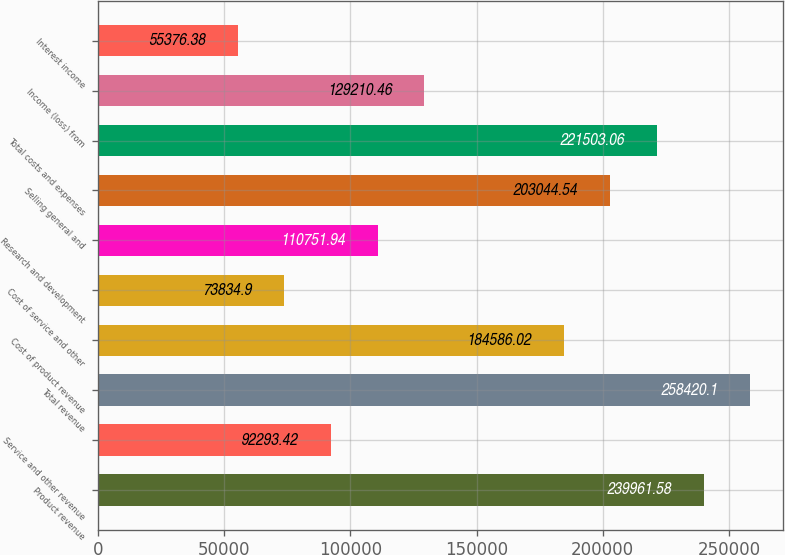<chart> <loc_0><loc_0><loc_500><loc_500><bar_chart><fcel>Product revenue<fcel>Service and other revenue<fcel>Total revenue<fcel>Cost of product revenue<fcel>Cost of service and other<fcel>Research and development<fcel>Selling general and<fcel>Total costs and expenses<fcel>Income (loss) from<fcel>Interest income<nl><fcel>239962<fcel>92293.4<fcel>258420<fcel>184586<fcel>73834.9<fcel>110752<fcel>203045<fcel>221503<fcel>129210<fcel>55376.4<nl></chart> 